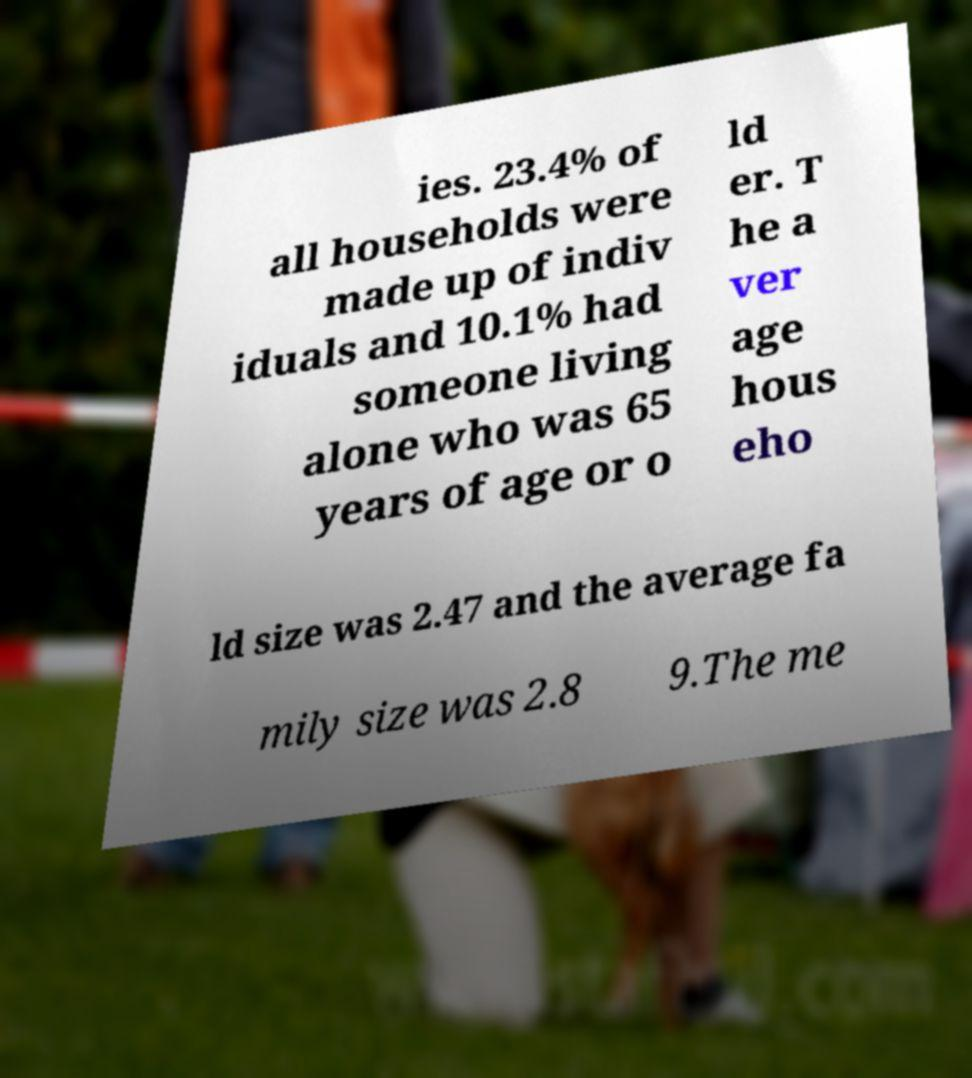Can you read and provide the text displayed in the image?This photo seems to have some interesting text. Can you extract and type it out for me? ies. 23.4% of all households were made up of indiv iduals and 10.1% had someone living alone who was 65 years of age or o ld er. T he a ver age hous eho ld size was 2.47 and the average fa mily size was 2.8 9.The me 